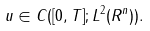<formula> <loc_0><loc_0><loc_500><loc_500>u \in C ( [ 0 , T ] ; L ^ { 2 } ( R ^ { n } ) ) .</formula> 